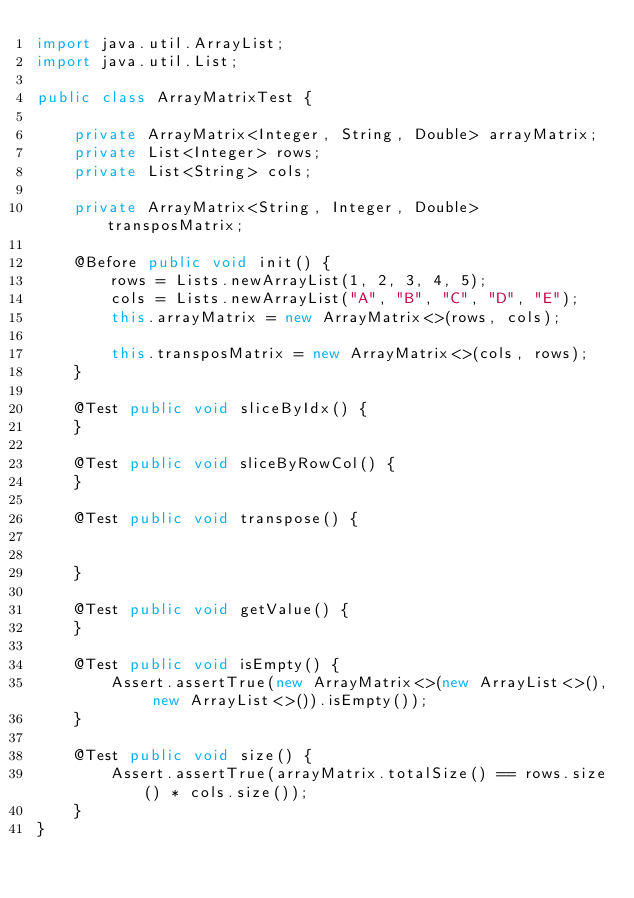Convert code to text. <code><loc_0><loc_0><loc_500><loc_500><_Java_>import java.util.ArrayList;
import java.util.List;

public class ArrayMatrixTest {
    
    private ArrayMatrix<Integer, String, Double> arrayMatrix;
    private List<Integer> rows;
    private List<String> cols;
    
    private ArrayMatrix<String, Integer, Double> transposMatrix;
    
    @Before public void init() {
        rows = Lists.newArrayList(1, 2, 3, 4, 5);
        cols = Lists.newArrayList("A", "B", "C", "D", "E");
        this.arrayMatrix = new ArrayMatrix<>(rows, cols);
        
        this.transposMatrix = new ArrayMatrix<>(cols, rows);
    }
    
    @Test public void sliceByIdx() {
    }
    
    @Test public void sliceByRowCol() {
    }
    
    @Test public void transpose() {
    
    
    }
    
    @Test public void getValue() {
    }
    
    @Test public void isEmpty() {
        Assert.assertTrue(new ArrayMatrix<>(new ArrayList<>(), new ArrayList<>()).isEmpty());
    }
    
    @Test public void size() {
        Assert.assertTrue(arrayMatrix.totalSize() == rows.size() * cols.size());
    }
}</code> 